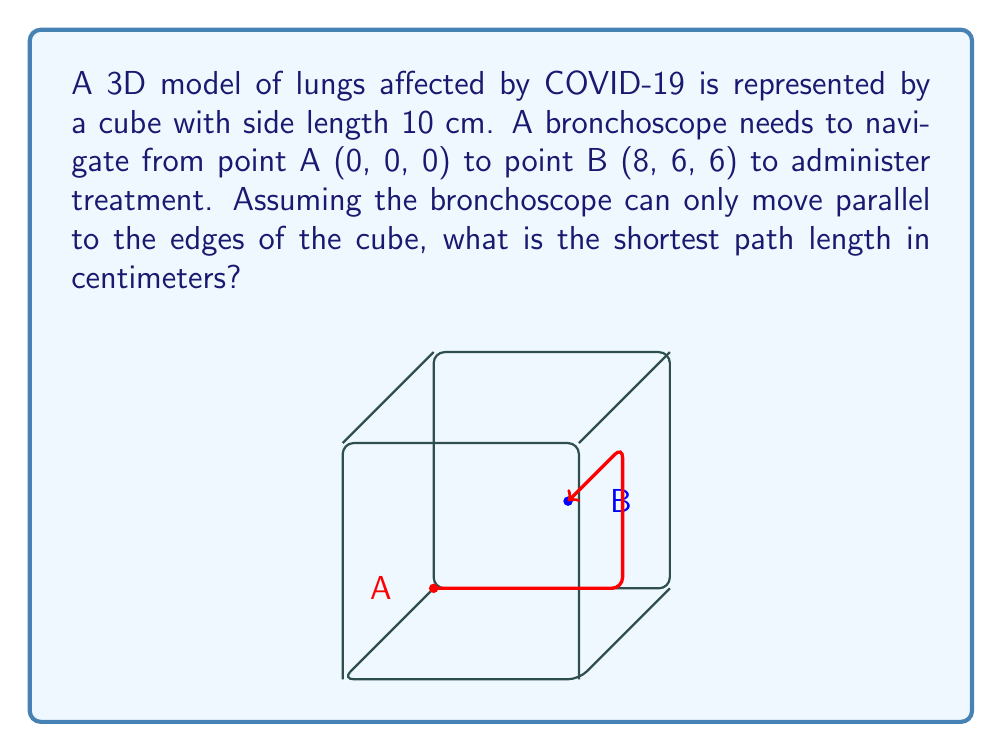Teach me how to tackle this problem. To find the shortest path through the 3D model of lungs, we need to calculate the Manhattan distance between points A and B. The Manhattan distance in 3D space is the sum of the absolute differences of their coordinates.

Let's break it down step-by-step:

1) The coordinates of point A are (0, 0, 0) and point B are (8, 6, 6).

2) Calculate the absolute differences for each coordinate:
   x-coordinate: |8 - 0| = 8
   y-coordinate: |6 - 0| = 6
   z-coordinate: |6 - 0| = 6

3) The Manhattan distance is the sum of these differences:
   $$\text{Distance} = |x_2 - x_1| + |y_2 - y_1| + |z_2 - z_1|$$
   $$\text{Distance} = 8 + 6 + 6 = 20$$

4) Since the cube has a side length of 10 cm, the actual distance in centimeters is:
   $$\text{Actual Distance} = 20 \times 1 \text{ cm} = 20 \text{ cm}$$

This path represents the bronchoscope moving 8 cm along the x-axis, then 6 cm along the y-axis, and finally 6 cm along the z-axis to reach the treatment point B.
Answer: 20 cm 